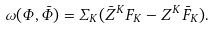Convert formula to latex. <formula><loc_0><loc_0><loc_500><loc_500>\omega ( \Phi , \bar { \Phi } ) = \Sigma _ { K } ( \bar { Z } ^ { K } F _ { K } - Z ^ { K } \bar { F } _ { K } ) .</formula> 